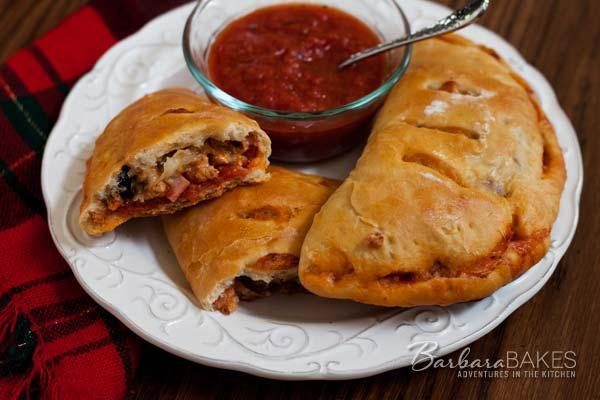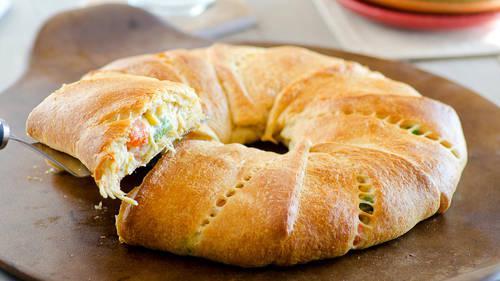The first image is the image on the left, the second image is the image on the right. Given the left and right images, does the statement "In the left image the food is on a white plate." hold true? Answer yes or no. Yes. The first image is the image on the left, the second image is the image on the right. Considering the images on both sides, is "The left image shows calzones on a non-white plate." valid? Answer yes or no. No. 